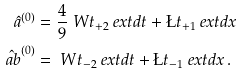<formula> <loc_0><loc_0><loc_500><loc_500>\hat { a } ^ { ( 0 ) } & = \frac { 4 } { 9 } \ W t _ { + 2 } \ e x t d t + \L t _ { + 1 } \ e x t d x \\ \hat { \ a b } ^ { ( 0 ) } & = \ W t _ { - 2 } \ e x t d t + \L t _ { - 1 } \ e x t d x \, .</formula> 